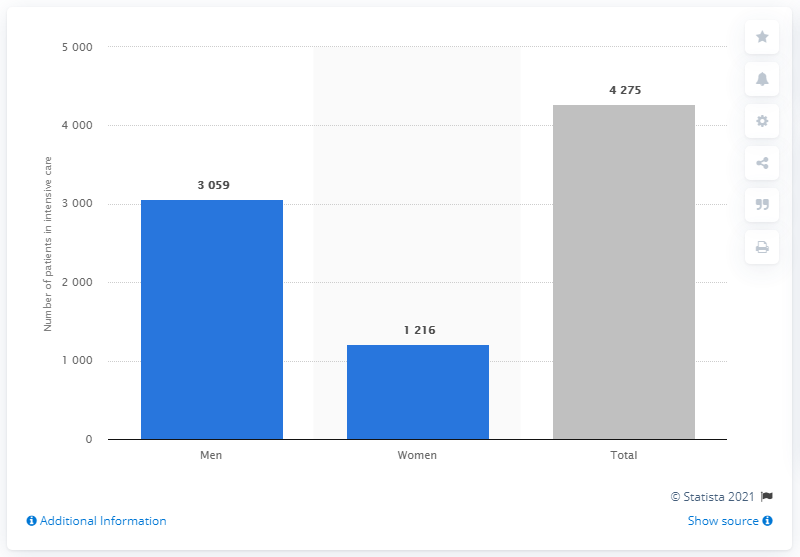Do men or women have more COVID number of of coronavirus patients in intensive care in Sweden? According to the provided bar chart, men have a higher number of COVID-19 patients in intensive care in Sweden, with a total of 3,059 male patients compared to 1,216 female patients. This data highlights a significant gender disparity in the severity of cases requiring intensive care. 